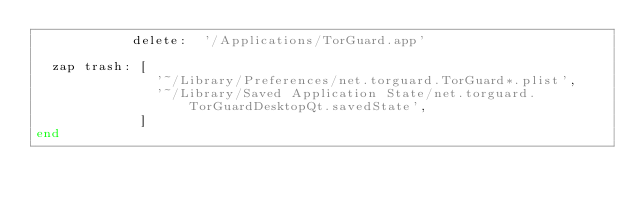Convert code to text. <code><loc_0><loc_0><loc_500><loc_500><_Ruby_>            delete:  '/Applications/TorGuard.app'

  zap trash: [
               '~/Library/Preferences/net.torguard.TorGuard*.plist',
               '~/Library/Saved Application State/net.torguard.TorGuardDesktopQt.savedState',
             ]
end
</code> 